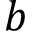<formula> <loc_0><loc_0><loc_500><loc_500>b</formula> 